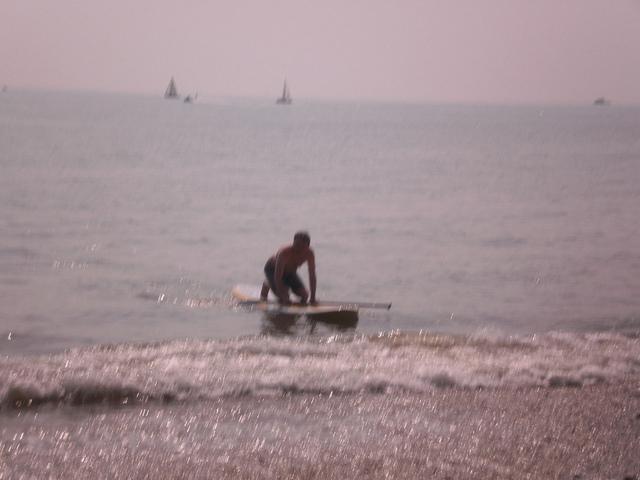What is the person riding?
Quick response, please. Surfboard. Is it winter?
Concise answer only. No. Are the waves high enough for surfing?
Be succinct. No. What's the man doing?
Write a very short answer. Surfing. Is he standing on his surfboard?
Be succinct. No. Where is this picture taken?
Keep it brief. Beach. Are there sailboats on the water?
Be succinct. Yes. 